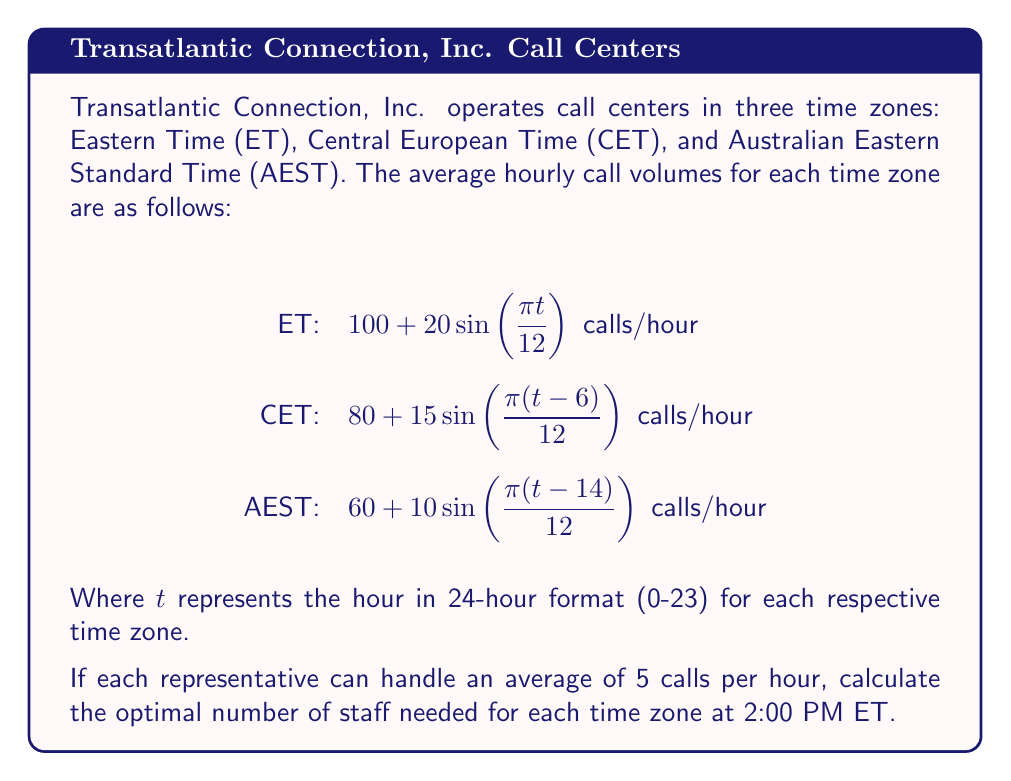Provide a solution to this math problem. To solve this problem, we need to follow these steps:

1. Determine the corresponding times for each time zone at 2:00 PM ET:
   ET: 2:00 PM (14:00)
   CET: 8:00 PM (20:00) (ET + 6 hours)
   AEST: 4:00 AM next day (04:00) (ET + 14 hours)

2. Calculate the call volume for each time zone using the given formulas:

   For ET ($t = 14$):
   $$100 + 20\sin(\frac{\pi \cdot 14}{12}) = 100 + 20\sin(\frac{7\pi}{6}) \approx 89.64$$

   For CET ($t = 20$):
   $$80 + 15\sin(\frac{\pi (20-6)}{12}) = 80 + 15\sin(\frac{7\pi}{6}) \approx 72.73$$

   For AEST ($t = 4$):
   $$60 + 10\sin(\frac{\pi (4-14)}{12}) = 60 + 10\sin(-\frac{5\pi}{6}) \approx 51.34$$

3. Calculate the number of staff needed for each time zone:
   Divide the call volume by the average calls handled per representative (5 calls/hour) and round up to the nearest whole number.

   ET: $\lceil \frac{89.64}{5} \rceil = \lceil 17.93 \rceil = 18$ staff members

   CET: $\lceil \frac{72.73}{5} \rceil = \lceil 14.55 \rceil = 15$ staff members

   AEST: $\lceil \frac{51.34}{5} \rceil = \lceil 10.27 \rceil = 11$ staff members

Therefore, the optimal staffing levels at 2:00 PM ET are 18 for ET, 15 for CET, and 11 for AEST.
Answer: ET: 18, CET: 15, AEST: 11 